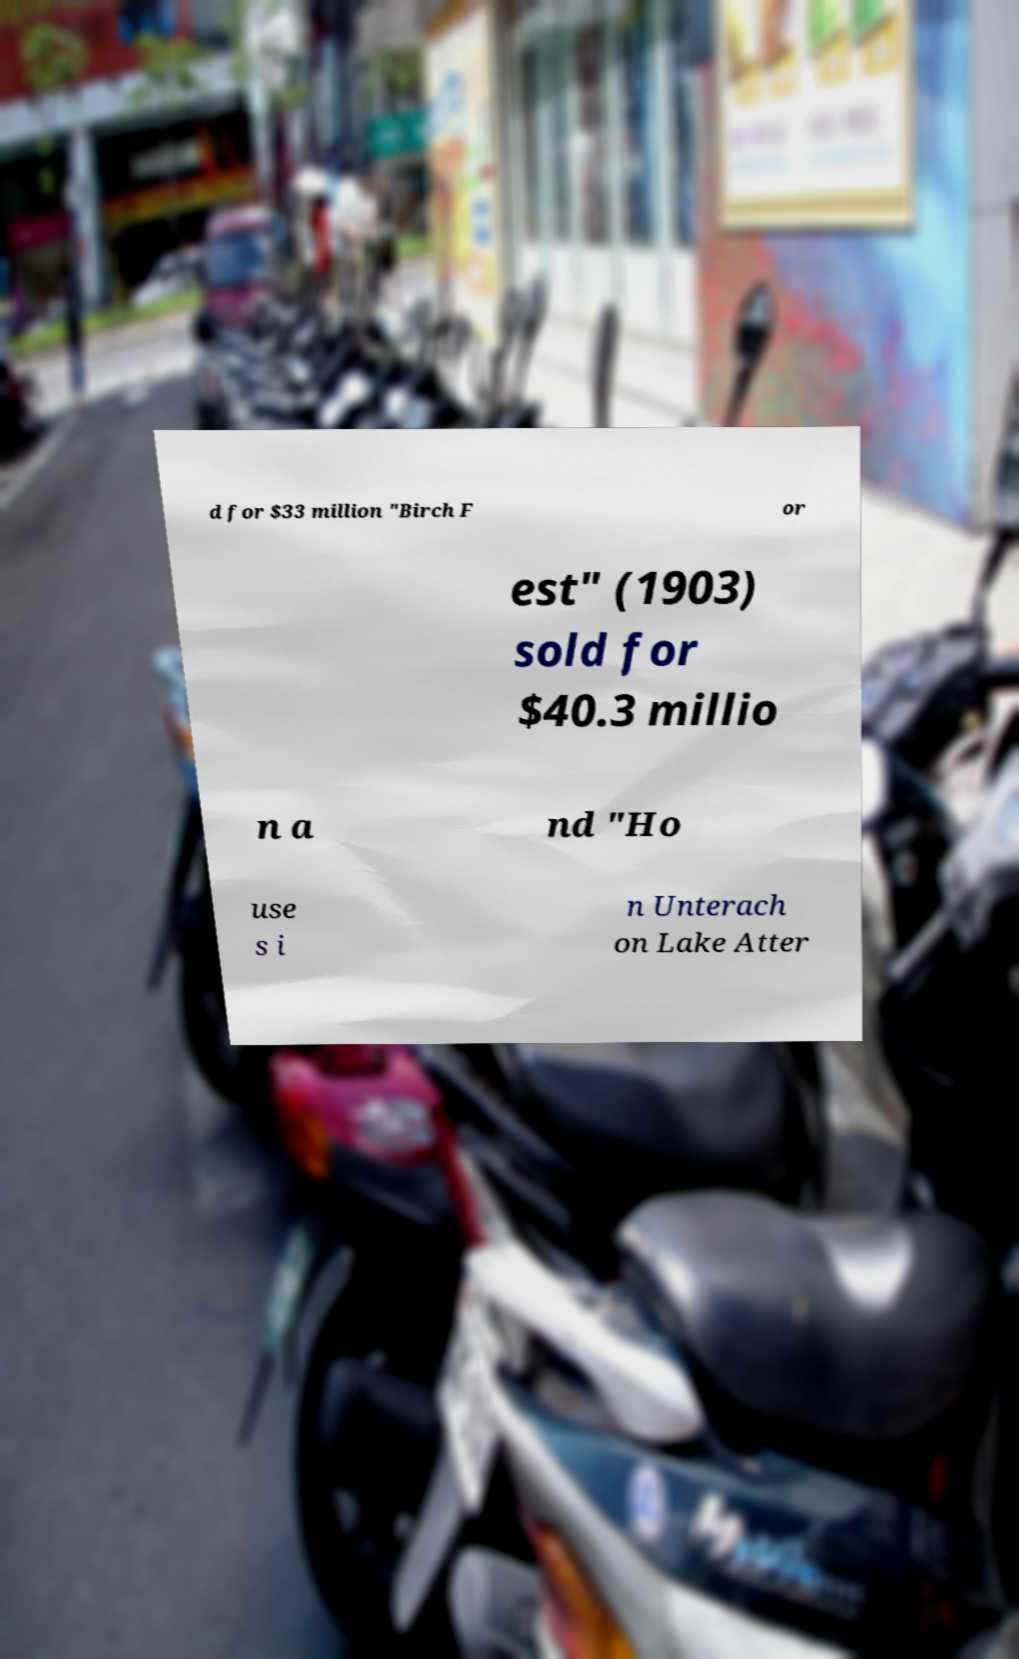What messages or text are displayed in this image? I need them in a readable, typed format. d for $33 million "Birch F or est" (1903) sold for $40.3 millio n a nd "Ho use s i n Unterach on Lake Atter 